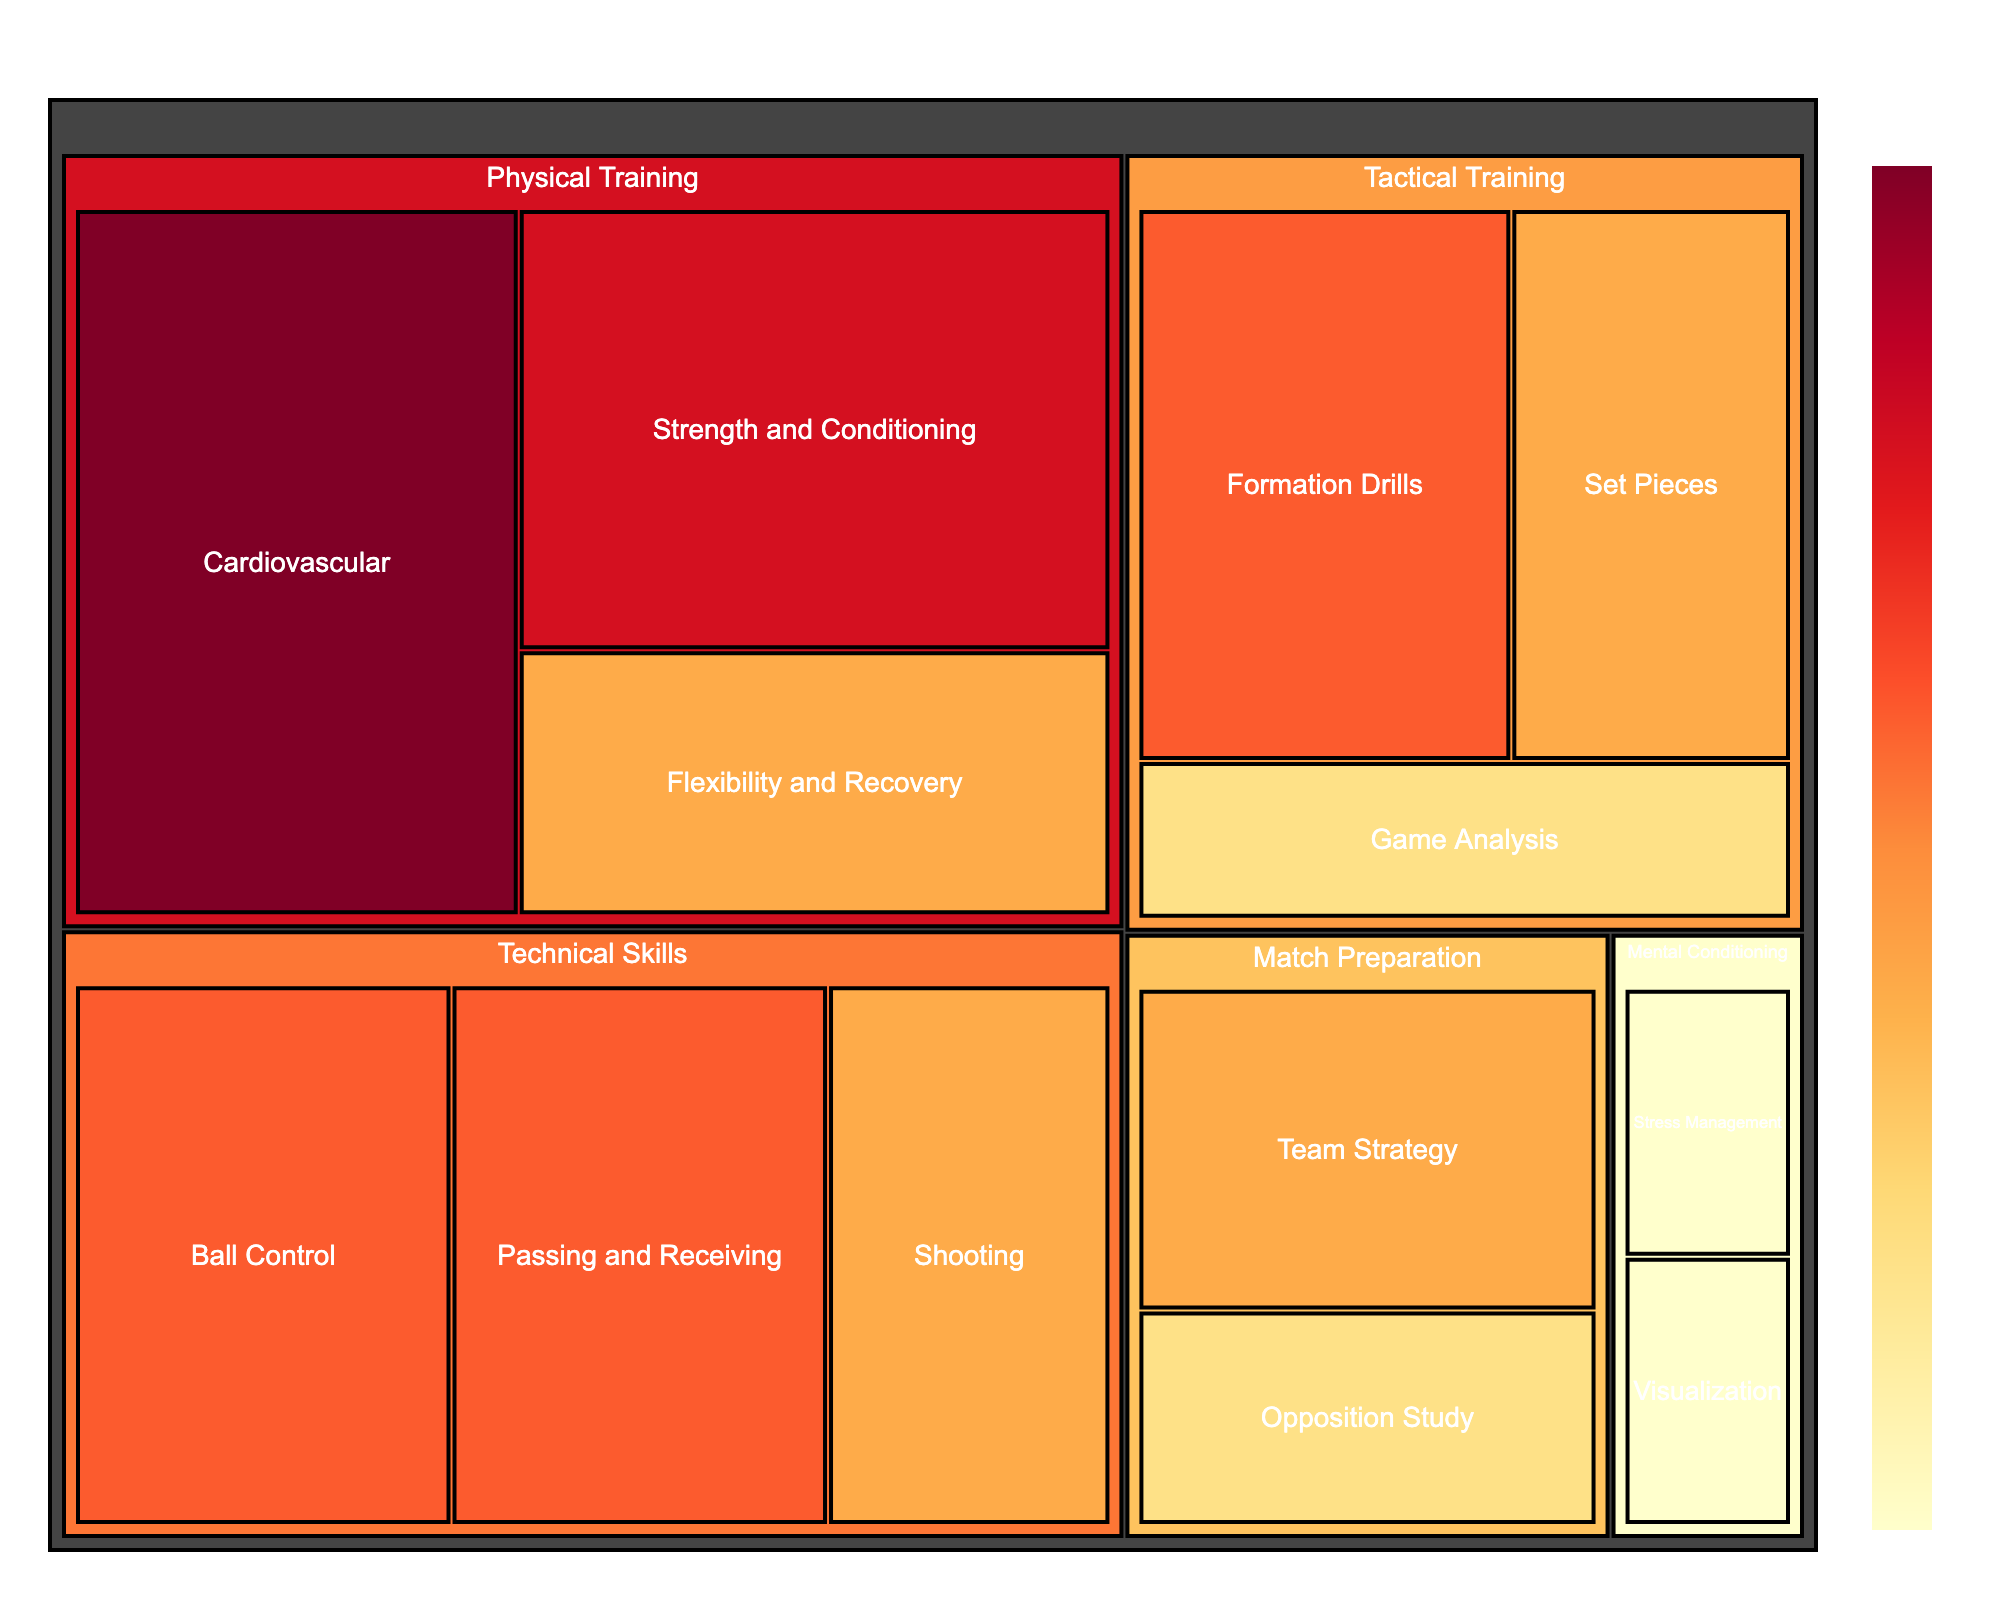What's the title of the figure? The title of the figure is displayed prominently at the top, which is standard practice for giving a quick summary of what the data represents.
Answer: Yeovil Town FC: Weekly Training Allocation How many hours in total are allocated to Physical Training? To find the total hours for Physical Training, sum up the hours of all its subcategories: Cardiovascular (6) + Strength and Conditioning (5) + Flexibility and Recovery (3).
Answer: 14 Which skill area receives the least training time? By looking at the amount of hours allocated in each skill area, the one with the smallest number indicates the least amount of training time.
Answer: Mental Conditioning How many subcategories are there under Technical Skills? Count the number of distinct subcategories listed under the Technical Skills category in the treemap.
Answer: 3 Compare the training time between Tactical Training and Match Preparation. Which one has more hours, and by how much? Sum the hours for Tactical Training (Formation Drills (4) + Set Pieces (3) + Game Analysis (2) = 9) and Match Preparation (Opposition Study (2) + Team Strategy (3) = 5), then subtract the smaller number from the larger one.
Answer: Tactical Training has 4 more hours Identify the subcategory with the highest training time under Physical Training and its allocated hours. Look under the Physical Training category and identify the subcategory with the highest number of hours allocated.
Answer: Cardiovascular, 6 hours What is the combined training time for Set Pieces and Ball Control? Add the hours allocated to Set Pieces (3) and Ball Control (4).
Answer: 7 hours What percentage of the total training time is spent on Flexibility and Recovery? First, calculate the total training hours by summing all subcategories' hours. Then divide the hours for Flexibility and Recovery by the total hours and multiply by 100 to find the percentage. Total hours = 42. (3/42) * 100 = 7.14%.
Answer: 7.14% Which subcategory has more training hours: Visualization or Stress Management? Compare the training hours directly from the treemap's subcategories under Mental Conditioning.
Answer: Both have 1 hour What is the difference in hours between Team Strategy and Game Analysis? Subtract the hours allocated to Game Analysis from those allocated to Team Strategy.
Answer: 1 hour 